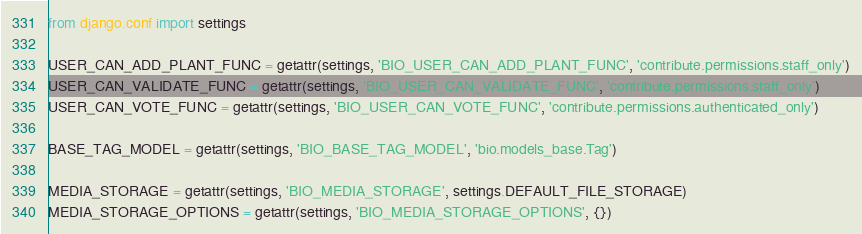Convert code to text. <code><loc_0><loc_0><loc_500><loc_500><_Python_>from django.conf import settings

USER_CAN_ADD_PLANT_FUNC = getattr(settings, 'BIO_USER_CAN_ADD_PLANT_FUNC', 'contribute.permissions.staff_only')
USER_CAN_VALIDATE_FUNC = getattr(settings, 'BIO_USER_CAN_VALIDATE_FUNC', 'contribute.permissions.staff_only')
USER_CAN_VOTE_FUNC = getattr(settings, 'BIO_USER_CAN_VOTE_FUNC', 'contribute.permissions.authenticated_only')

BASE_TAG_MODEL = getattr(settings, 'BIO_BASE_TAG_MODEL', 'bio.models_base.Tag')

MEDIA_STORAGE = getattr(settings, 'BIO_MEDIA_STORAGE', settings.DEFAULT_FILE_STORAGE)
MEDIA_STORAGE_OPTIONS = getattr(settings, 'BIO_MEDIA_STORAGE_OPTIONS', {})
</code> 